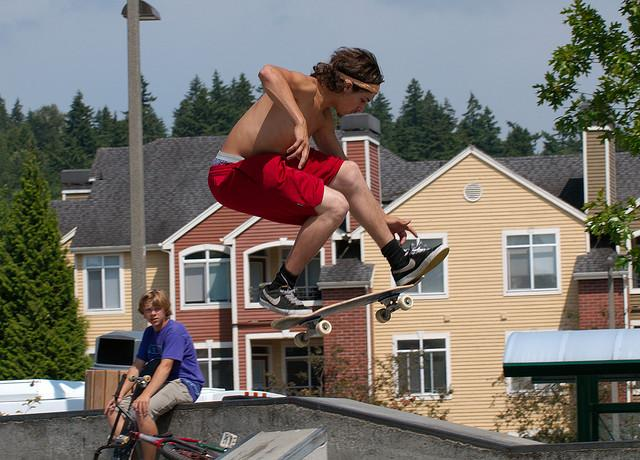What muscle do skater jumps Work? leg 